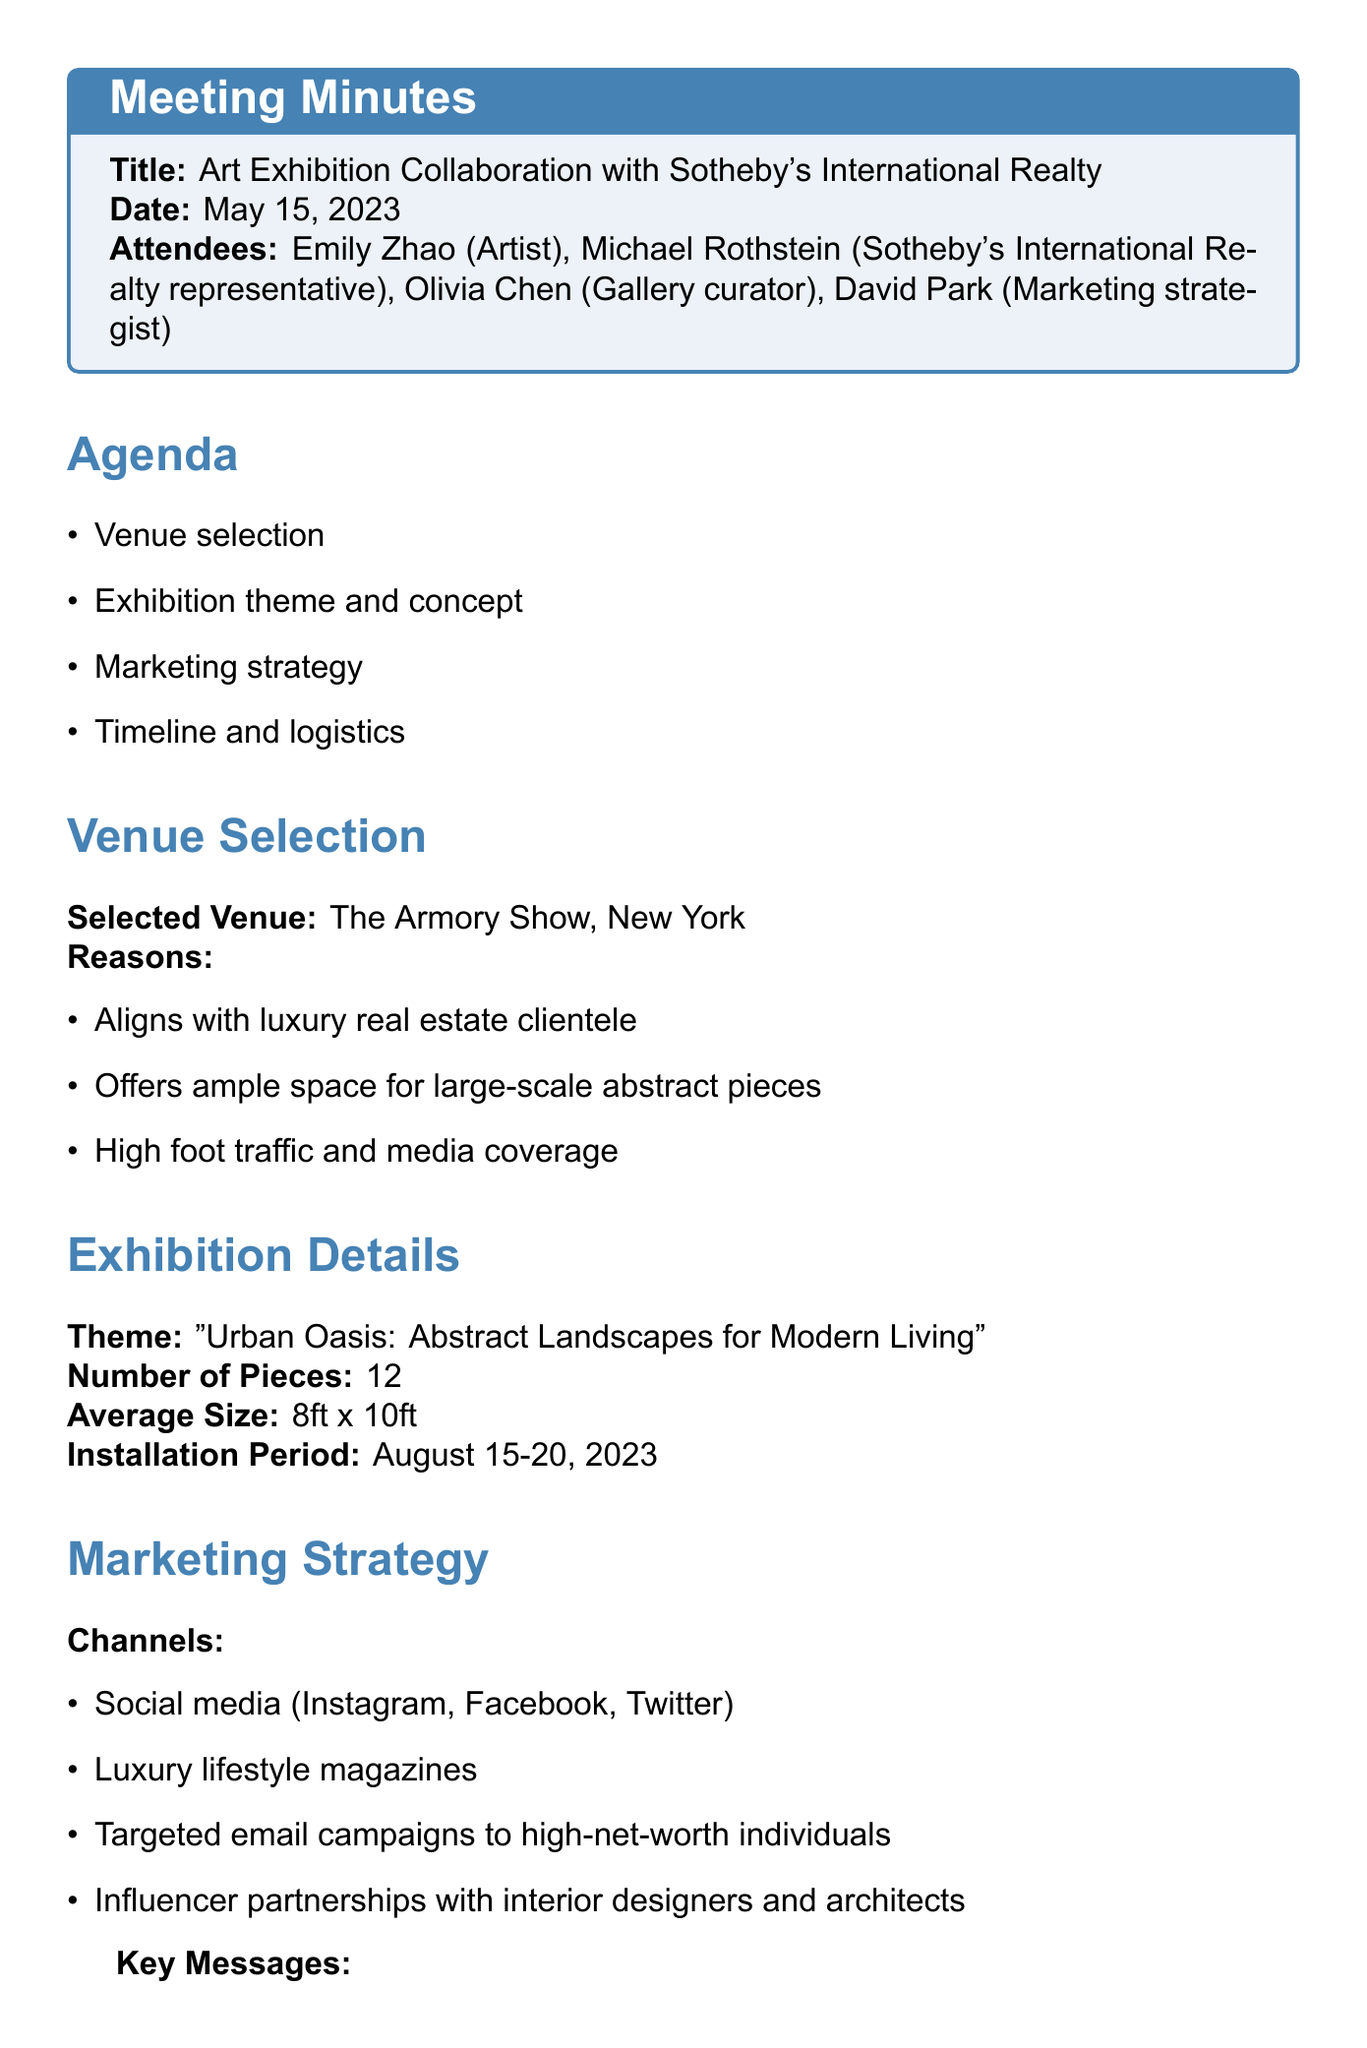what is the date of the meeting? The date of the meeting is listed in the document under the title section, which states "May 15, 2023."
Answer: May 15, 2023 who is the artist mentioned in the meeting? The name of the artist is listed among the attendees of the meeting.
Answer: Emily Zhao what is the selected venue for the exhibition? The selected venue is mentioned in the venue selection section.
Answer: The Armory Show, New York how many pieces will be exhibited? The number of pieces is provided in the exhibition details section.
Answer: 12 what is the theme of the exhibition? The theme is specifically stated in the exhibition details section.
Answer: Urban Oasis: Abstract Landscapes for Modern Living which marketing channel is mentioned first? The first marketing channel is listed in the marketing strategy section.
Answer: Social media (Instagram, Facebook, Twitter) when is the marketing launch scheduled? The marketing launch date can be found in the timeline section of the document.
Answer: July 1, 2023 who is responsible for securing the venue contract? The action items list who is tasked with securing the venue contract.
Answer: Michael what is the installation period for the artwork? The installation period is found in the exhibition details section.
Answer: August 15-20, 2023 